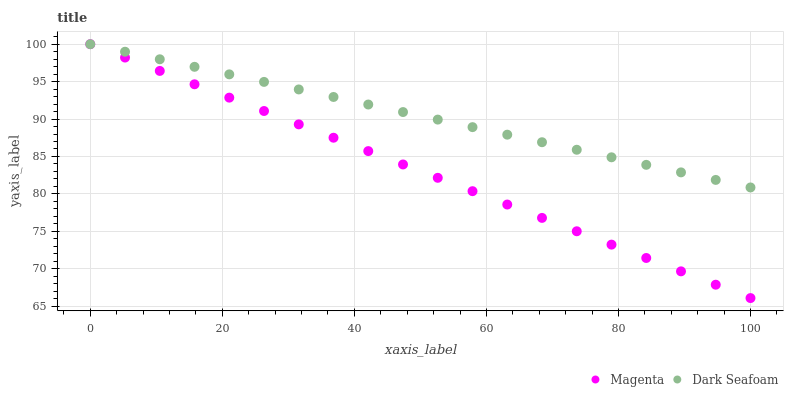Does Magenta have the minimum area under the curve?
Answer yes or no. Yes. Does Dark Seafoam have the maximum area under the curve?
Answer yes or no. Yes. Does Dark Seafoam have the minimum area under the curve?
Answer yes or no. No. Is Dark Seafoam the smoothest?
Answer yes or no. Yes. Is Magenta the roughest?
Answer yes or no. Yes. Is Dark Seafoam the roughest?
Answer yes or no. No. Does Magenta have the lowest value?
Answer yes or no. Yes. Does Dark Seafoam have the lowest value?
Answer yes or no. No. Does Dark Seafoam have the highest value?
Answer yes or no. Yes. Does Magenta intersect Dark Seafoam?
Answer yes or no. Yes. Is Magenta less than Dark Seafoam?
Answer yes or no. No. Is Magenta greater than Dark Seafoam?
Answer yes or no. No. 